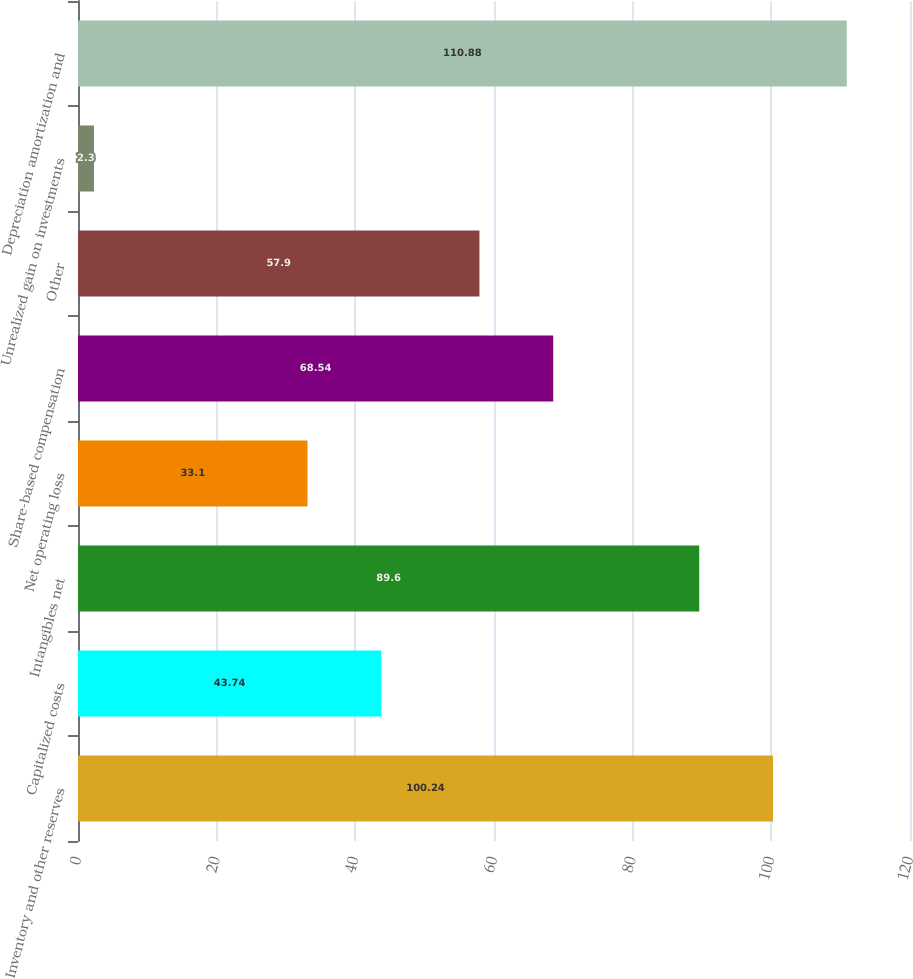<chart> <loc_0><loc_0><loc_500><loc_500><bar_chart><fcel>Inventory and other reserves<fcel>Capitalized costs<fcel>Intangibles net<fcel>Net operating loss<fcel>Share-based compensation<fcel>Other<fcel>Unrealized gain on investments<fcel>Depreciation amortization and<nl><fcel>100.24<fcel>43.74<fcel>89.6<fcel>33.1<fcel>68.54<fcel>57.9<fcel>2.3<fcel>110.88<nl></chart> 